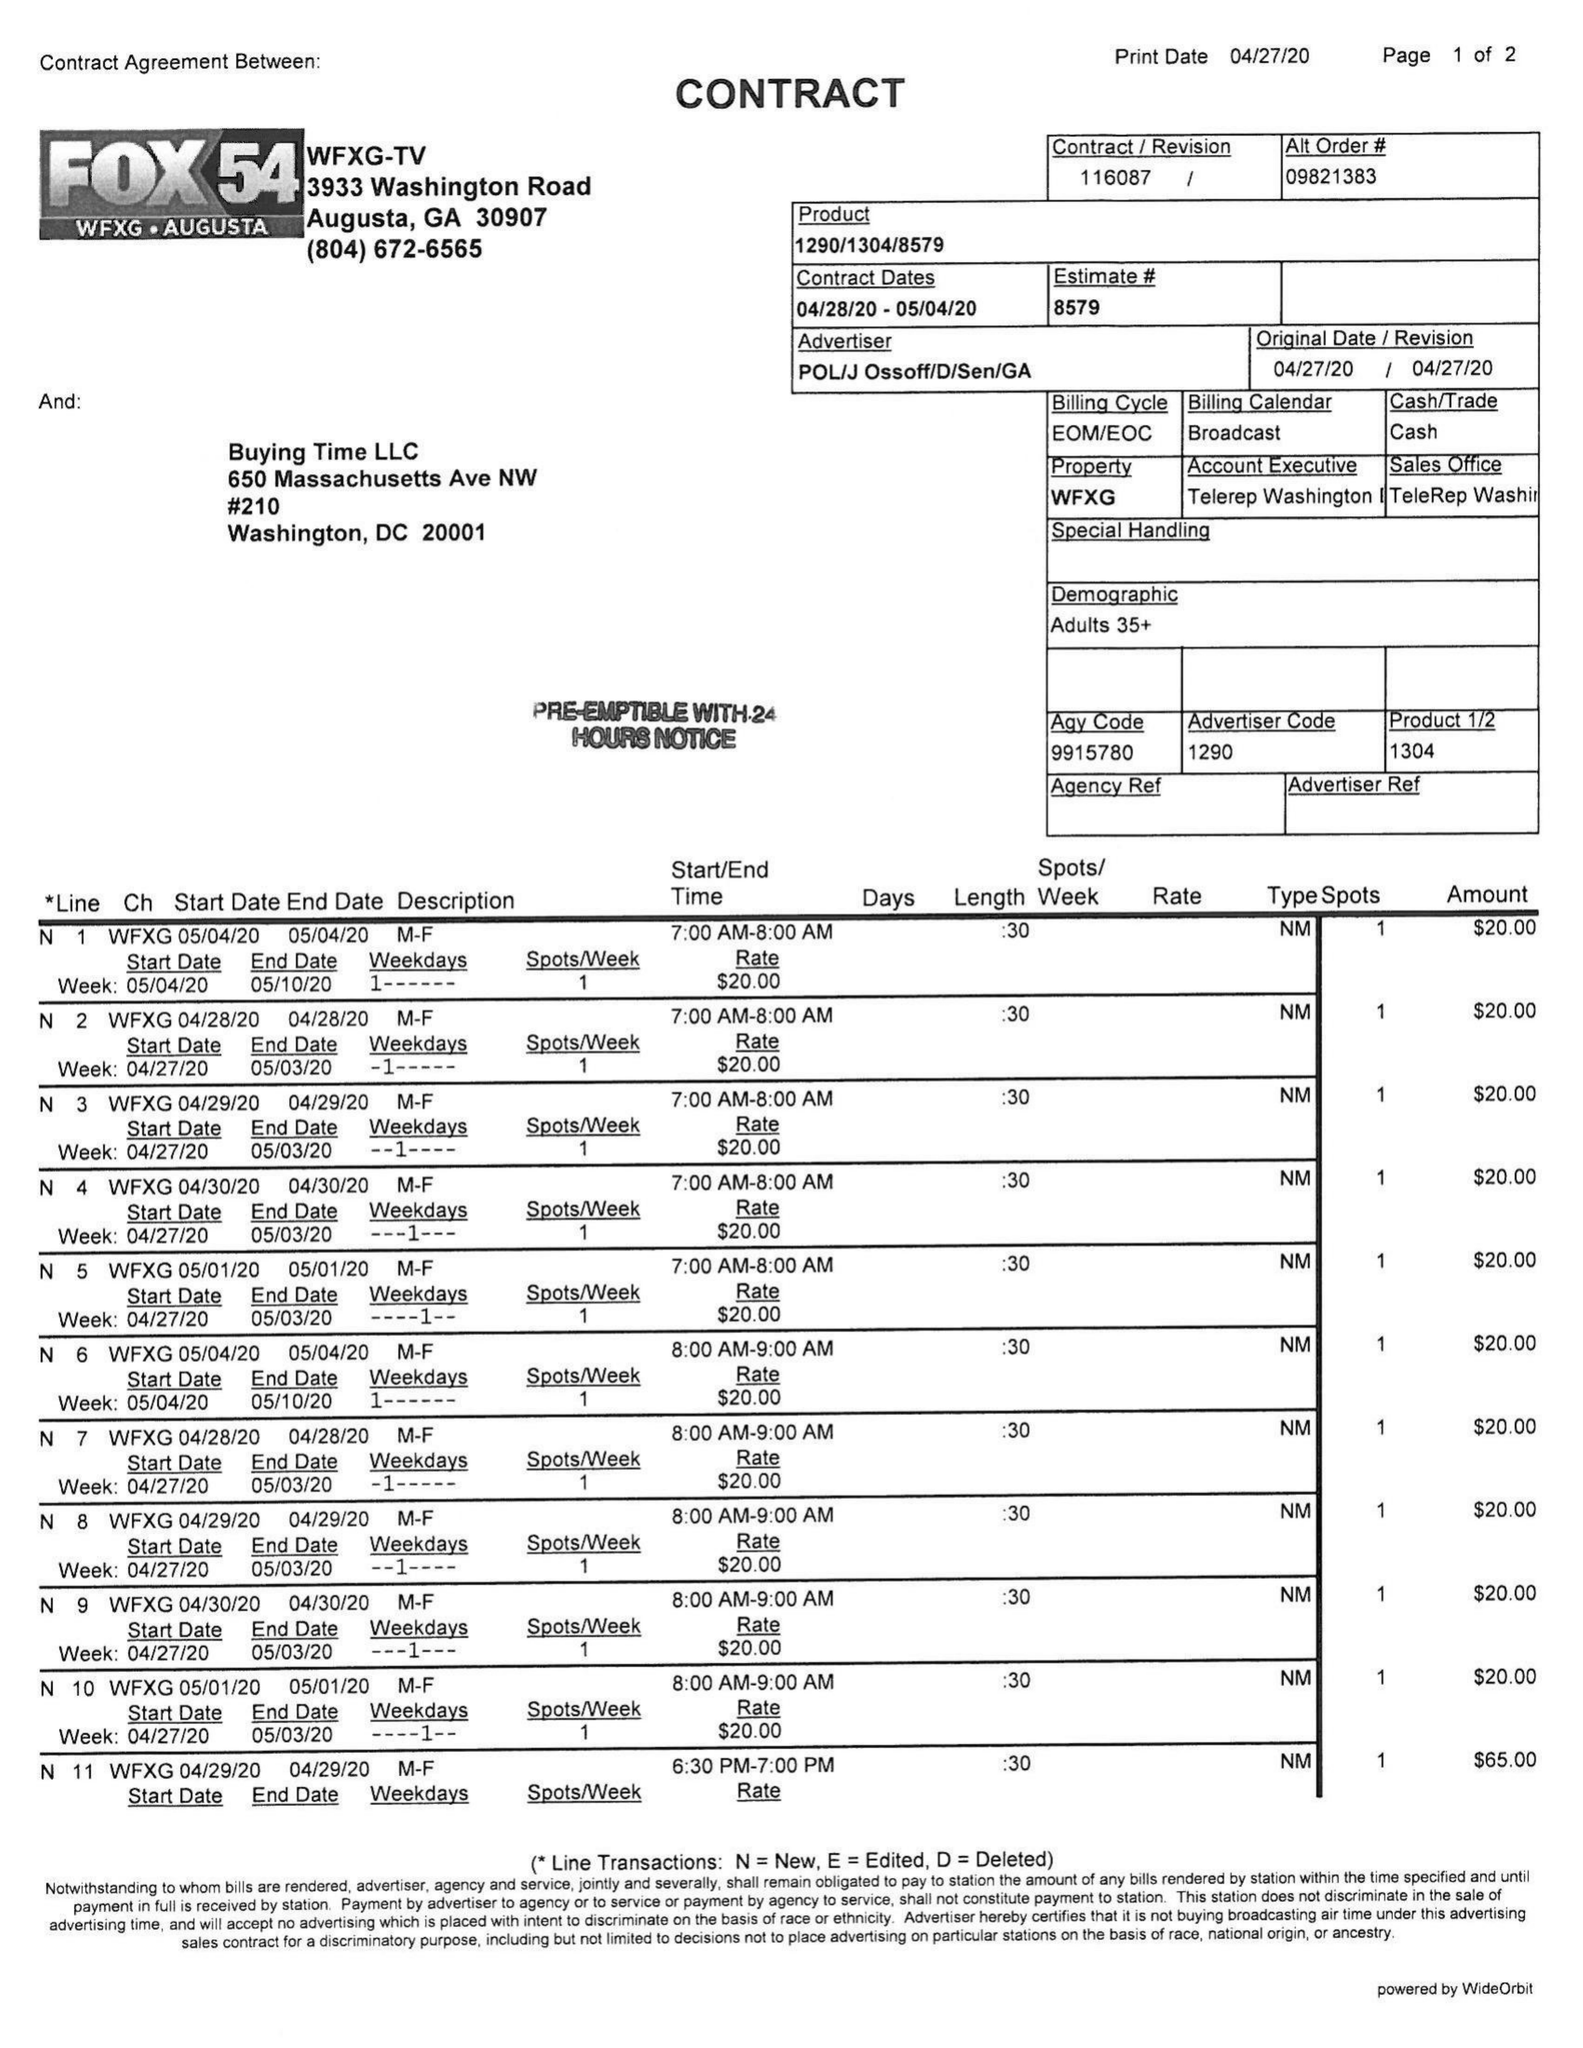What is the value for the contract_num?
Answer the question using a single word or phrase. 116087 